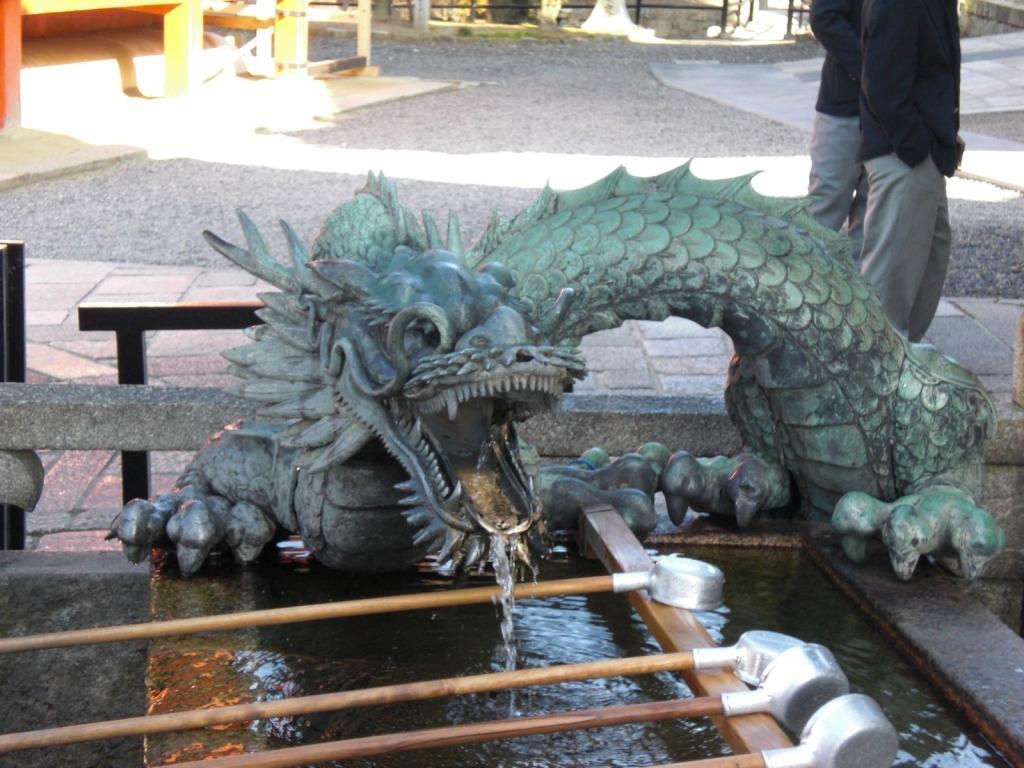Describe this image in one or two sentences. In this image, we can see some water. We can also see a some poles on a wooden object. We can see a statue. We can see the ground with some objects. There are a few people. We can also see some black colored objects. 